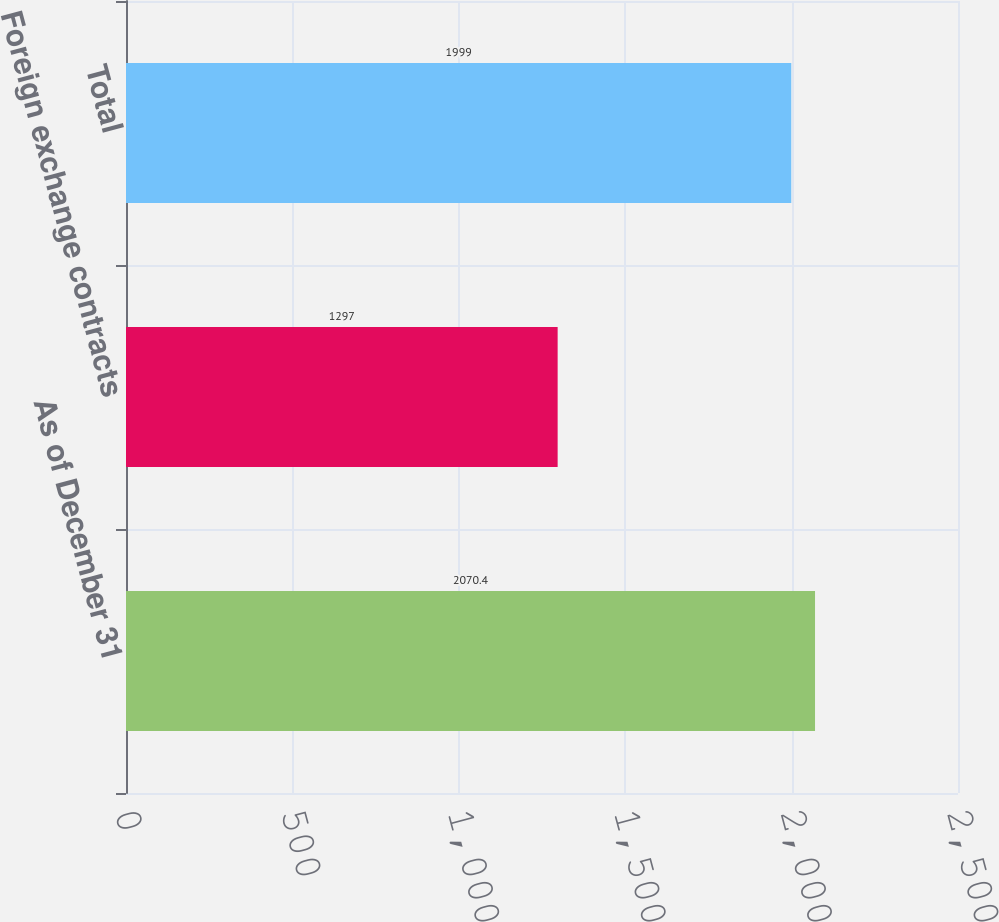Convert chart. <chart><loc_0><loc_0><loc_500><loc_500><bar_chart><fcel>As of December 31<fcel>Foreign exchange contracts<fcel>Total<nl><fcel>2070.4<fcel>1297<fcel>1999<nl></chart> 